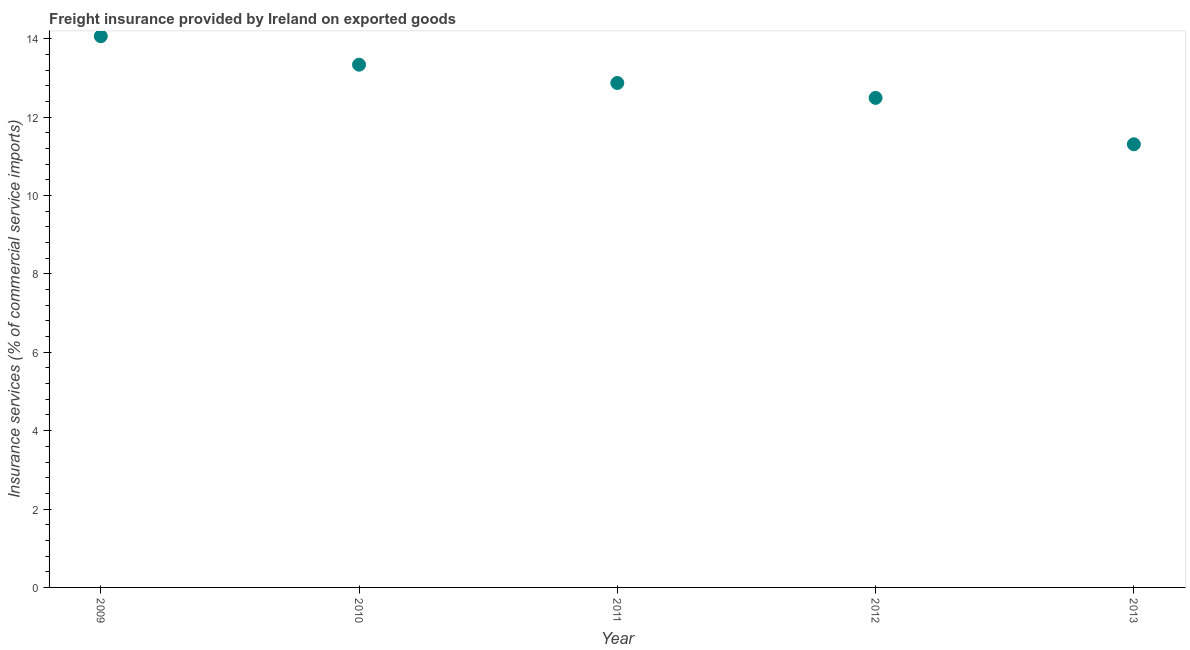What is the freight insurance in 2009?
Your answer should be compact. 14.06. Across all years, what is the maximum freight insurance?
Provide a short and direct response. 14.06. Across all years, what is the minimum freight insurance?
Your response must be concise. 11.31. In which year was the freight insurance maximum?
Keep it short and to the point. 2009. In which year was the freight insurance minimum?
Your response must be concise. 2013. What is the sum of the freight insurance?
Your answer should be compact. 64.07. What is the difference between the freight insurance in 2010 and 2011?
Provide a succinct answer. 0.47. What is the average freight insurance per year?
Your response must be concise. 12.81. What is the median freight insurance?
Offer a terse response. 12.87. In how many years, is the freight insurance greater than 1.2000000000000002 %?
Offer a terse response. 5. What is the ratio of the freight insurance in 2009 to that in 2012?
Provide a short and direct response. 1.13. What is the difference between the highest and the second highest freight insurance?
Offer a terse response. 0.73. Is the sum of the freight insurance in 2010 and 2011 greater than the maximum freight insurance across all years?
Give a very brief answer. Yes. What is the difference between the highest and the lowest freight insurance?
Your response must be concise. 2.76. In how many years, is the freight insurance greater than the average freight insurance taken over all years?
Your answer should be compact. 3. How many dotlines are there?
Keep it short and to the point. 1. Does the graph contain any zero values?
Keep it short and to the point. No. Does the graph contain grids?
Your answer should be very brief. No. What is the title of the graph?
Give a very brief answer. Freight insurance provided by Ireland on exported goods . What is the label or title of the X-axis?
Make the answer very short. Year. What is the label or title of the Y-axis?
Offer a very short reply. Insurance services (% of commercial service imports). What is the Insurance services (% of commercial service imports) in 2009?
Your answer should be very brief. 14.06. What is the Insurance services (% of commercial service imports) in 2010?
Your answer should be compact. 13.34. What is the Insurance services (% of commercial service imports) in 2011?
Offer a very short reply. 12.87. What is the Insurance services (% of commercial service imports) in 2012?
Provide a succinct answer. 12.49. What is the Insurance services (% of commercial service imports) in 2013?
Your answer should be very brief. 11.31. What is the difference between the Insurance services (% of commercial service imports) in 2009 and 2010?
Provide a succinct answer. 0.73. What is the difference between the Insurance services (% of commercial service imports) in 2009 and 2011?
Your answer should be very brief. 1.19. What is the difference between the Insurance services (% of commercial service imports) in 2009 and 2012?
Offer a very short reply. 1.57. What is the difference between the Insurance services (% of commercial service imports) in 2009 and 2013?
Provide a succinct answer. 2.76. What is the difference between the Insurance services (% of commercial service imports) in 2010 and 2011?
Give a very brief answer. 0.47. What is the difference between the Insurance services (% of commercial service imports) in 2010 and 2012?
Make the answer very short. 0.85. What is the difference between the Insurance services (% of commercial service imports) in 2010 and 2013?
Give a very brief answer. 2.03. What is the difference between the Insurance services (% of commercial service imports) in 2011 and 2012?
Offer a very short reply. 0.38. What is the difference between the Insurance services (% of commercial service imports) in 2011 and 2013?
Offer a very short reply. 1.56. What is the difference between the Insurance services (% of commercial service imports) in 2012 and 2013?
Ensure brevity in your answer.  1.18. What is the ratio of the Insurance services (% of commercial service imports) in 2009 to that in 2010?
Offer a terse response. 1.05. What is the ratio of the Insurance services (% of commercial service imports) in 2009 to that in 2011?
Provide a succinct answer. 1.09. What is the ratio of the Insurance services (% of commercial service imports) in 2009 to that in 2012?
Keep it short and to the point. 1.13. What is the ratio of the Insurance services (% of commercial service imports) in 2009 to that in 2013?
Provide a short and direct response. 1.24. What is the ratio of the Insurance services (% of commercial service imports) in 2010 to that in 2011?
Your answer should be very brief. 1.04. What is the ratio of the Insurance services (% of commercial service imports) in 2010 to that in 2012?
Give a very brief answer. 1.07. What is the ratio of the Insurance services (% of commercial service imports) in 2010 to that in 2013?
Your answer should be very brief. 1.18. What is the ratio of the Insurance services (% of commercial service imports) in 2011 to that in 2013?
Offer a terse response. 1.14. What is the ratio of the Insurance services (% of commercial service imports) in 2012 to that in 2013?
Offer a terse response. 1.1. 